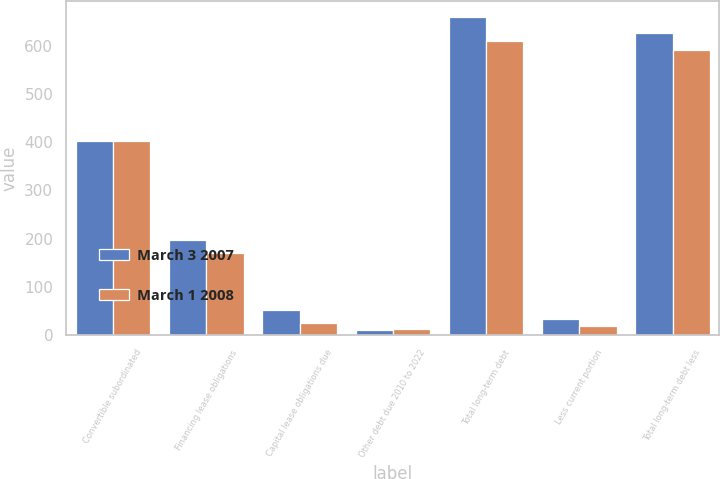Convert chart to OTSL. <chart><loc_0><loc_0><loc_500><loc_500><stacked_bar_chart><ecel><fcel>Convertible subordinated<fcel>Financing lease obligations<fcel>Capital lease obligations due<fcel>Other debt due 2010 to 2022<fcel>Total long-term debt<fcel>Less current portion<fcel>Total long-term debt less<nl><fcel>March 3 2007<fcel>402<fcel>197<fcel>51<fcel>10<fcel>660<fcel>33<fcel>627<nl><fcel>March 1 2008<fcel>402<fcel>171<fcel>24<fcel>12<fcel>609<fcel>19<fcel>590<nl></chart> 